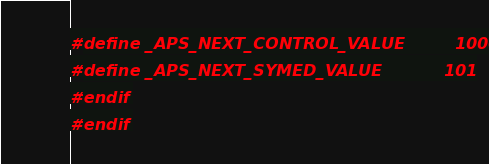<code> <loc_0><loc_0><loc_500><loc_500><_C_>#define _APS_NEXT_CONTROL_VALUE         1000
#define _APS_NEXT_SYMED_VALUE           101
#endif
#endif
</code> 